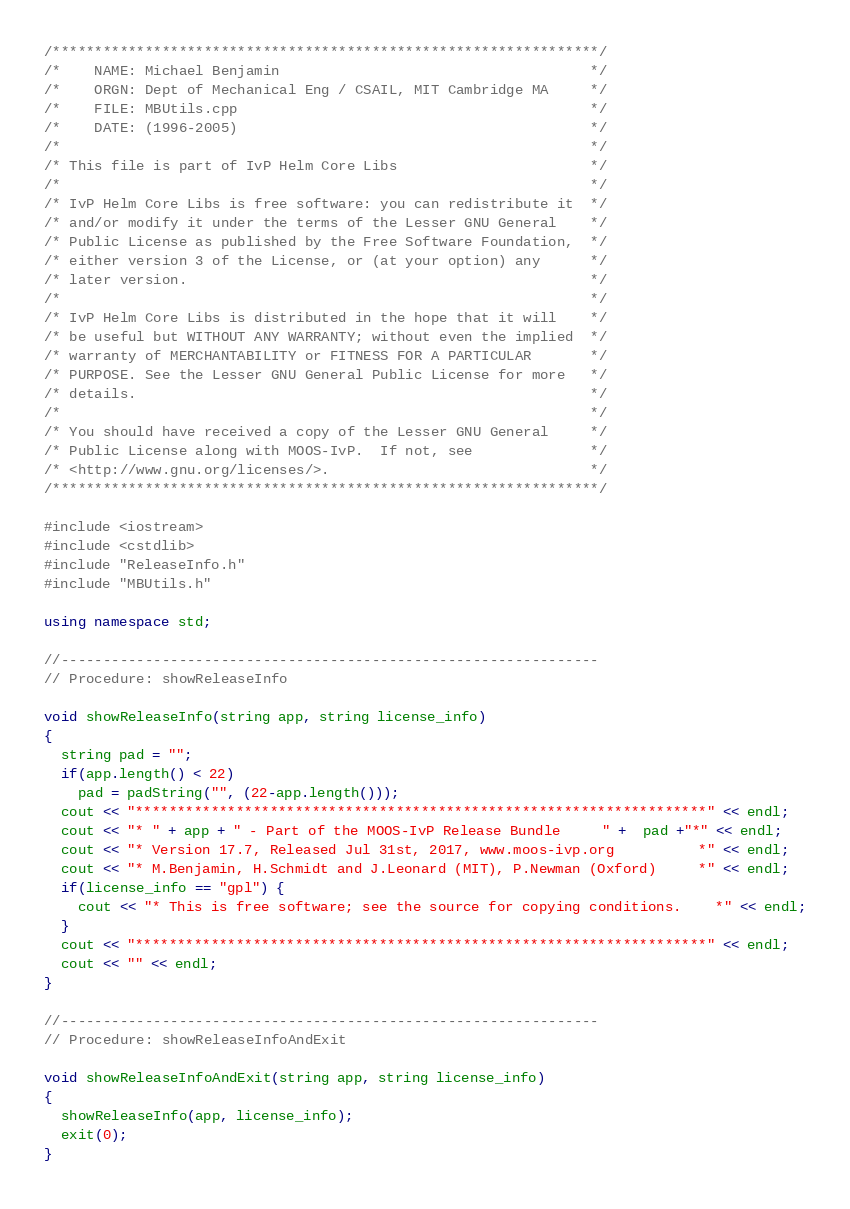<code> <loc_0><loc_0><loc_500><loc_500><_C++_>/*****************************************************************/
/*    NAME: Michael Benjamin                                     */
/*    ORGN: Dept of Mechanical Eng / CSAIL, MIT Cambridge MA     */
/*    FILE: MBUtils.cpp                                          */
/*    DATE: (1996-2005)                                          */
/*                                                               */
/* This file is part of IvP Helm Core Libs                       */
/*                                                               */
/* IvP Helm Core Libs is free software: you can redistribute it  */
/* and/or modify it under the terms of the Lesser GNU General    */
/* Public License as published by the Free Software Foundation,  */
/* either version 3 of the License, or (at your option) any      */
/* later version.                                                */
/*                                                               */
/* IvP Helm Core Libs is distributed in the hope that it will    */
/* be useful but WITHOUT ANY WARRANTY; without even the implied  */
/* warranty of MERCHANTABILITY or FITNESS FOR A PARTICULAR       */
/* PURPOSE. See the Lesser GNU General Public License for more   */
/* details.                                                      */
/*                                                               */
/* You should have received a copy of the Lesser GNU General     */
/* Public License along with MOOS-IvP.  If not, see              */
/* <http://www.gnu.org/licenses/>.                               */
/*****************************************************************/

#include <iostream>
#include <cstdlib>
#include "ReleaseInfo.h"
#include "MBUtils.h"

using namespace std;

//----------------------------------------------------------------
// Procedure: showReleaseInfo

void showReleaseInfo(string app, string license_info)
{
  string pad = "";
  if(app.length() < 22)
    pad = padString("", (22-app.length()));
  cout << "********************************************************************" << endl;
  cout << "* " + app + " - Part of the MOOS-IvP Release Bundle     " +  pad +"*" << endl;
  cout << "* Version 17.7, Released Jul 31st, 2017, www.moos-ivp.org          *" << endl;
  cout << "* M.Benjamin, H.Schmidt and J.Leonard (MIT), P.Newman (Oxford)     *" << endl;
  if(license_info == "gpl") {
    cout << "* This is free software; see the source for copying conditions.    *" << endl;
  }
  cout << "********************************************************************" << endl;
  cout << "" << endl;
}

//----------------------------------------------------------------
// Procedure: showReleaseInfoAndExit

void showReleaseInfoAndExit(string app, string license_info)
{
  showReleaseInfo(app, license_info);
  exit(0);
}






</code> 